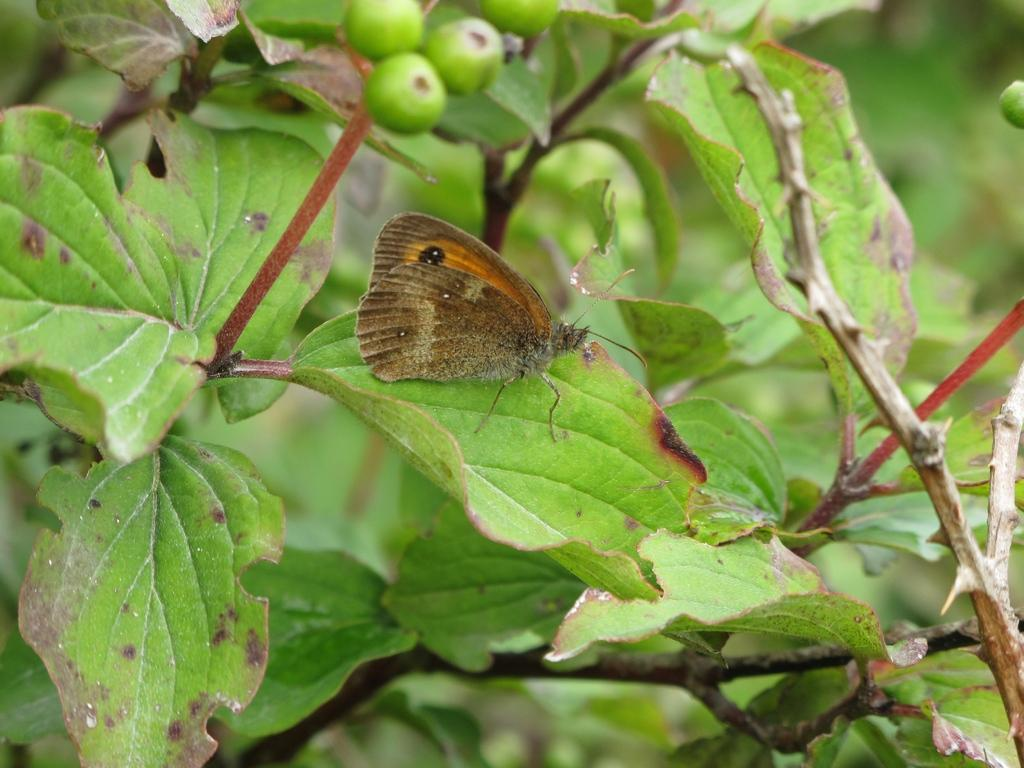What is the main subject of the image? There is a butterfly on a leaf in the image. What type of vegetation is present in the image? Leaves are present in the image, both in the foreground and background. What else can be seen in the background of the image? Stems are visible in the background of the image. Where is the cactus located in the image? There is no cactus present in the image. What type of loss is depicted in the image? There is no loss depicted in the image; it features a butterfly on a leaf with leaves and stems in the background. 